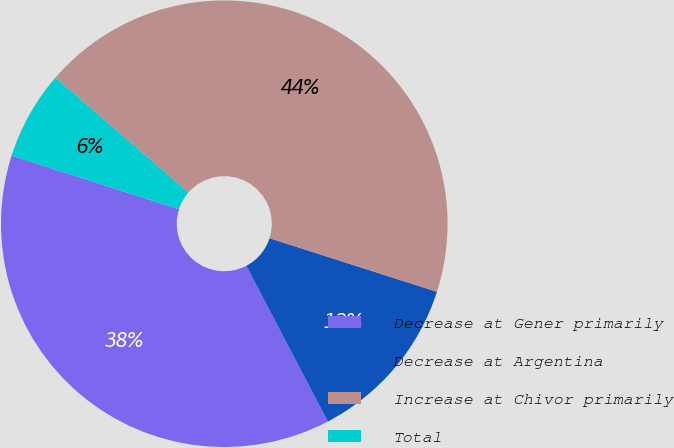Convert chart. <chart><loc_0><loc_0><loc_500><loc_500><pie_chart><fcel>Decrease at Gener primarily<fcel>Decrease at Argentina<fcel>Increase at Chivor primarily<fcel>Total<nl><fcel>37.61%<fcel>12.39%<fcel>43.58%<fcel>6.42%<nl></chart> 